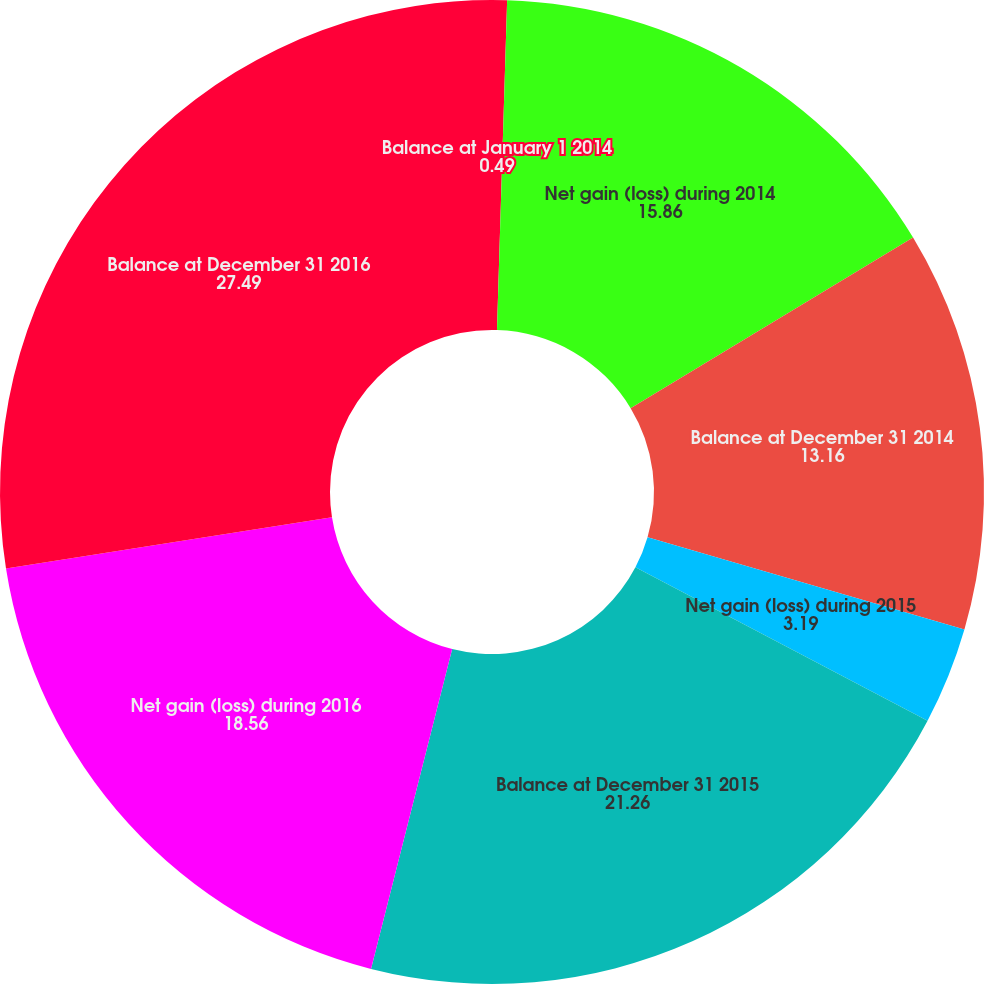<chart> <loc_0><loc_0><loc_500><loc_500><pie_chart><fcel>Balance at January 1 2014<fcel>Net gain (loss) during 2014<fcel>Balance at December 31 2014<fcel>Net gain (loss) during 2015<fcel>Balance at December 31 2015<fcel>Net gain (loss) during 2016<fcel>Balance at December 31 2016<nl><fcel>0.49%<fcel>15.86%<fcel>13.16%<fcel>3.19%<fcel>21.26%<fcel>18.56%<fcel>27.49%<nl></chart> 